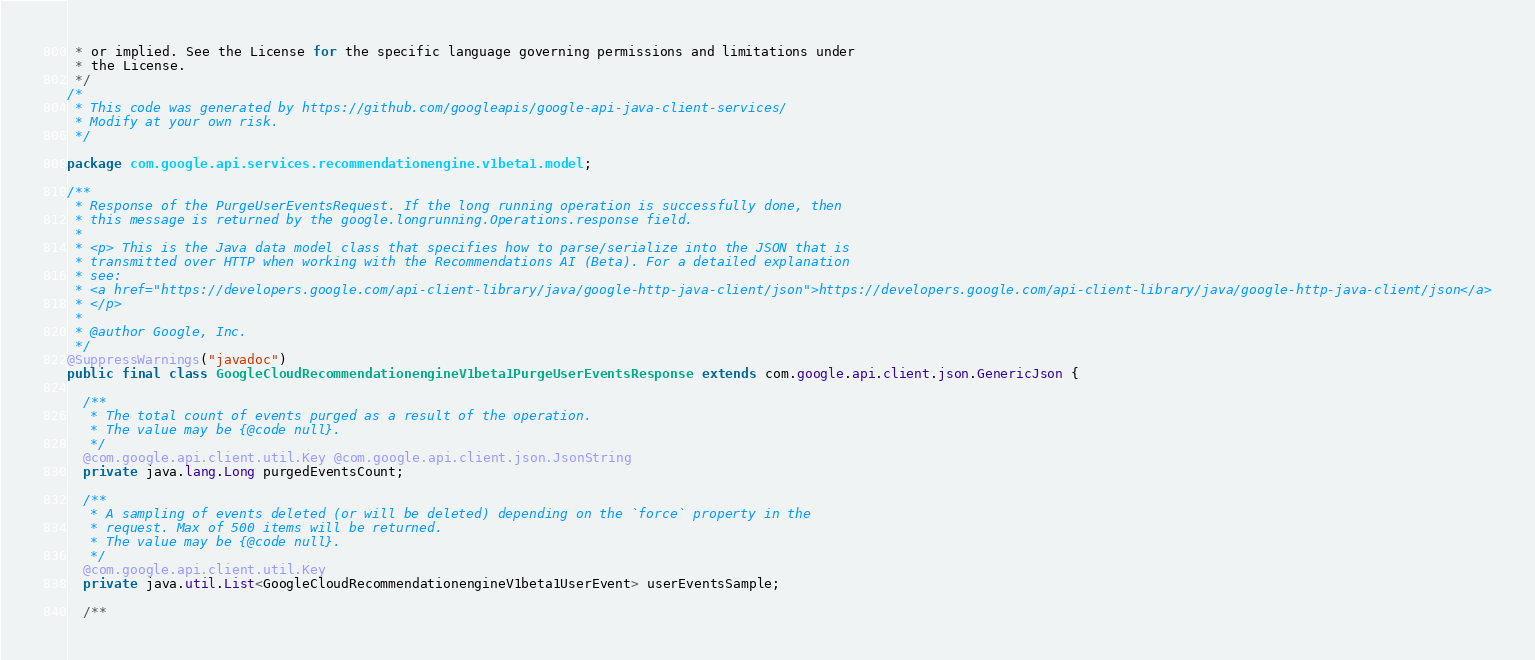<code> <loc_0><loc_0><loc_500><loc_500><_Java_> * or implied. See the License for the specific language governing permissions and limitations under
 * the License.
 */
/*
 * This code was generated by https://github.com/googleapis/google-api-java-client-services/
 * Modify at your own risk.
 */

package com.google.api.services.recommendationengine.v1beta1.model;

/**
 * Response of the PurgeUserEventsRequest. If the long running operation is successfully done, then
 * this message is returned by the google.longrunning.Operations.response field.
 *
 * <p> This is the Java data model class that specifies how to parse/serialize into the JSON that is
 * transmitted over HTTP when working with the Recommendations AI (Beta). For a detailed explanation
 * see:
 * <a href="https://developers.google.com/api-client-library/java/google-http-java-client/json">https://developers.google.com/api-client-library/java/google-http-java-client/json</a>
 * </p>
 *
 * @author Google, Inc.
 */
@SuppressWarnings("javadoc")
public final class GoogleCloudRecommendationengineV1beta1PurgeUserEventsResponse extends com.google.api.client.json.GenericJson {

  /**
   * The total count of events purged as a result of the operation.
   * The value may be {@code null}.
   */
  @com.google.api.client.util.Key @com.google.api.client.json.JsonString
  private java.lang.Long purgedEventsCount;

  /**
   * A sampling of events deleted (or will be deleted) depending on the `force` property in the
   * request. Max of 500 items will be returned.
   * The value may be {@code null}.
   */
  @com.google.api.client.util.Key
  private java.util.List<GoogleCloudRecommendationengineV1beta1UserEvent> userEventsSample;

  /**</code> 